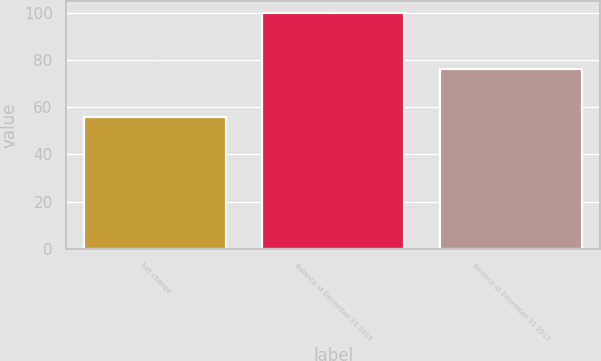Convert chart. <chart><loc_0><loc_0><loc_500><loc_500><bar_chart><fcel>Net change<fcel>Balance at December 31 2016<fcel>Balance at December 31 2017<nl><fcel>56<fcel>100<fcel>76<nl></chart> 